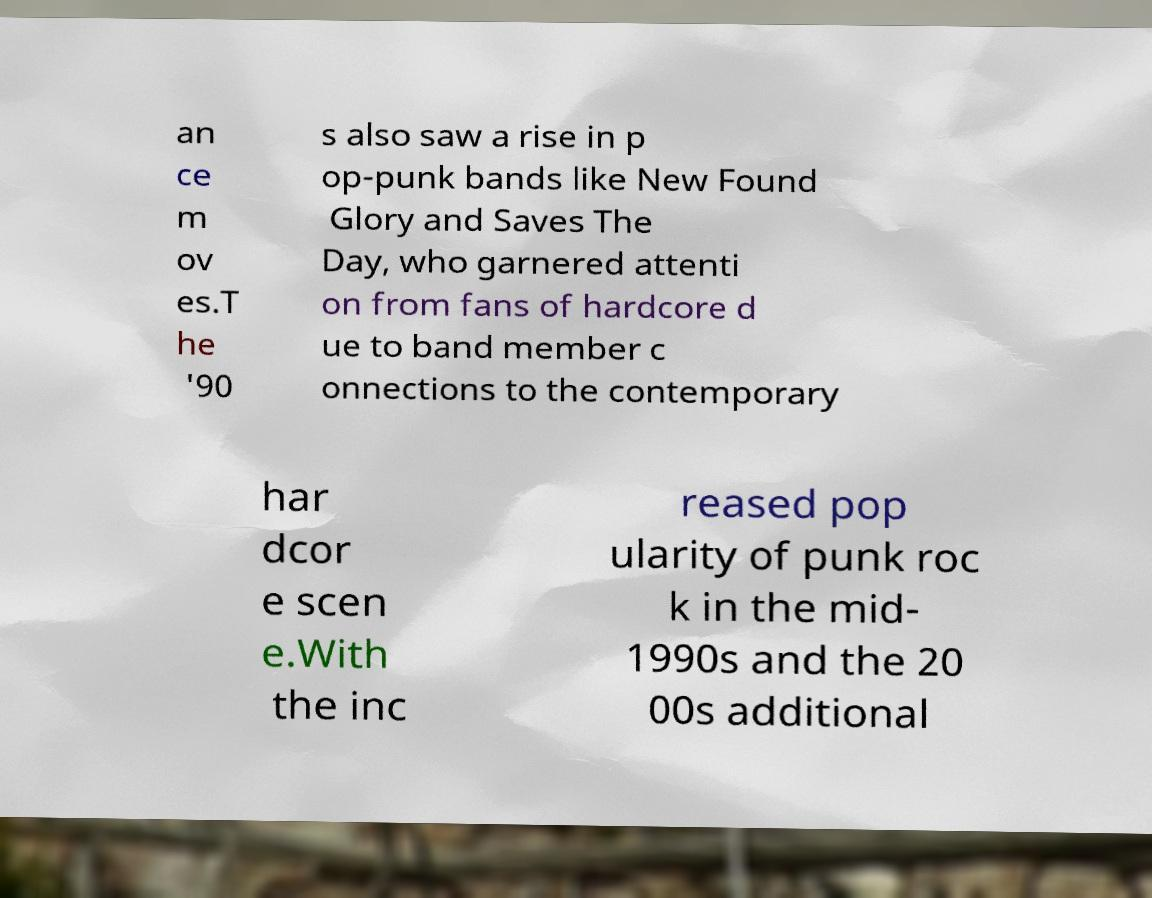Can you accurately transcribe the text from the provided image for me? an ce m ov es.T he '90 s also saw a rise in p op-punk bands like New Found Glory and Saves The Day, who garnered attenti on from fans of hardcore d ue to band member c onnections to the contemporary har dcor e scen e.With the inc reased pop ularity of punk roc k in the mid- 1990s and the 20 00s additional 